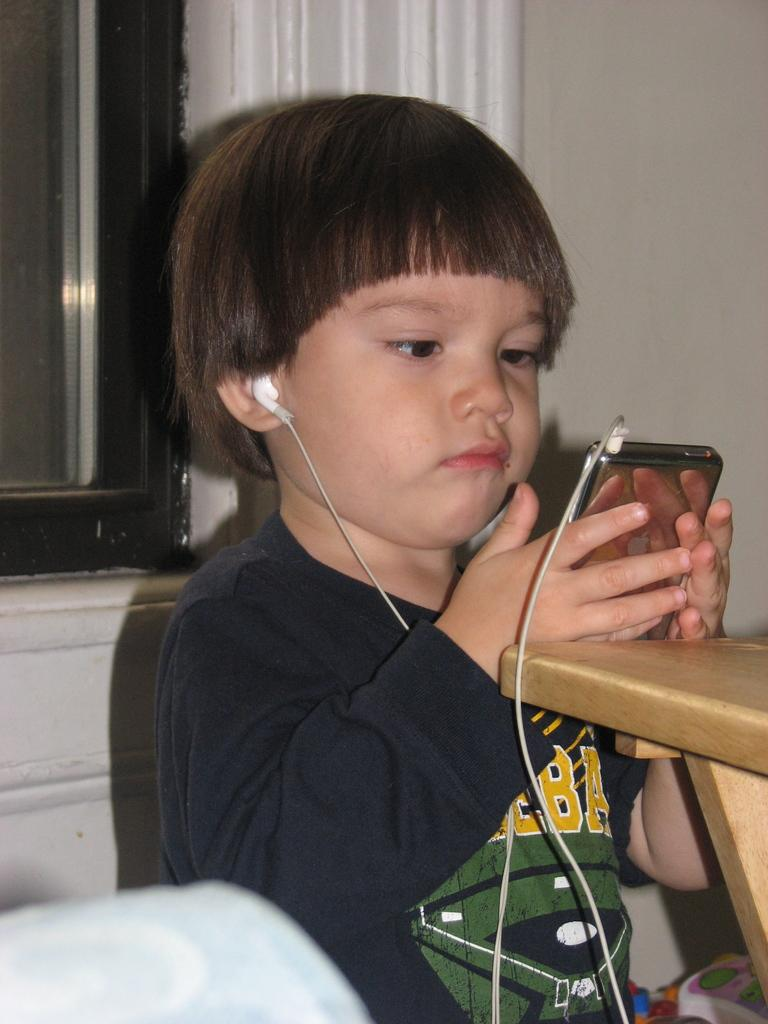What is the main subject of the image? There is a child in the image. What is the child holding in both hands? The child is holding a phone in both hands. What is connected to the phone? Earphones are plugged into the phone. What can be seen in the background of the image? There is a wall in the background of the image. What type of chicken is visible in the image? There is no chicken present in the image. What reward is the child receiving for using the phone? The image does not show any rewards being given to the child for using the phone. 